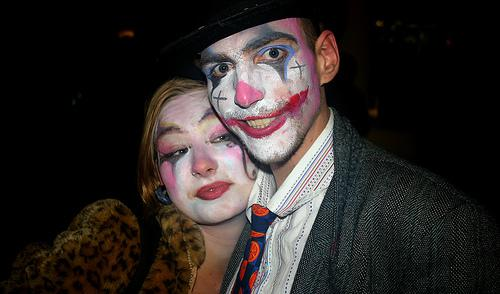Question: how many people are in the picture?
Choices:
A. 12.
B. 13.
C. 2.
D. 5.
Answer with the letter. Answer: C Question: why do the couple have their faces painted?
Choices:
A. Parade.
B. Fair.
C. Halloween costume.
D. Holiday.
Answer with the letter. Answer: C Question: what is the man's facial expression?
Choices:
A. Smiles.
B. Frown.
C. Crying.
D. Angry.
Answer with the letter. Answer: A Question: who is in the picture?
Choices:
A. A girl.
B. A man and woman.
C. An old man.
D. A mother.
Answer with the letter. Answer: B Question: when was the picture taken of the couple?
Choices:
A. Daytime.
B. Nighttime.
C. Evening.
D. Morning.
Answer with the letter. Answer: B 